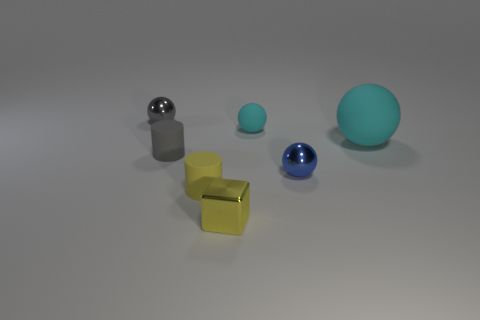Is the material of the gray thing that is to the right of the gray shiny object the same as the cube? Based on the visual clues, the gray object to the right of the shiny sphere looks like it could be made from a matte, plastic material, while the cube appears to have a reflective, possibly metallic surface. So, the materials are not the same as they exhibit different properties in terms of shininess and light reflection. 